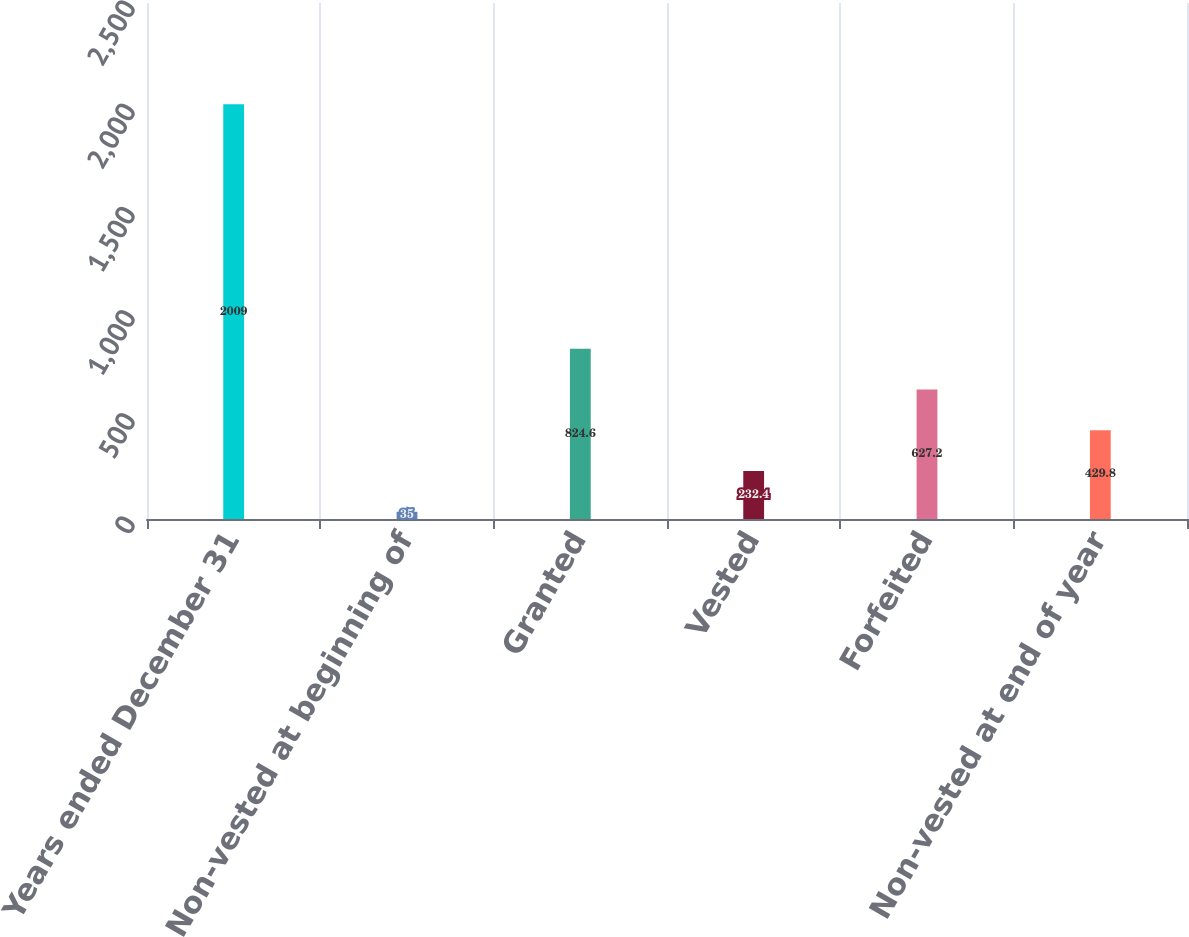<chart> <loc_0><loc_0><loc_500><loc_500><bar_chart><fcel>Years ended December 31<fcel>Non-vested at beginning of<fcel>Granted<fcel>Vested<fcel>Forfeited<fcel>Non-vested at end of year<nl><fcel>2009<fcel>35<fcel>824.6<fcel>232.4<fcel>627.2<fcel>429.8<nl></chart> 